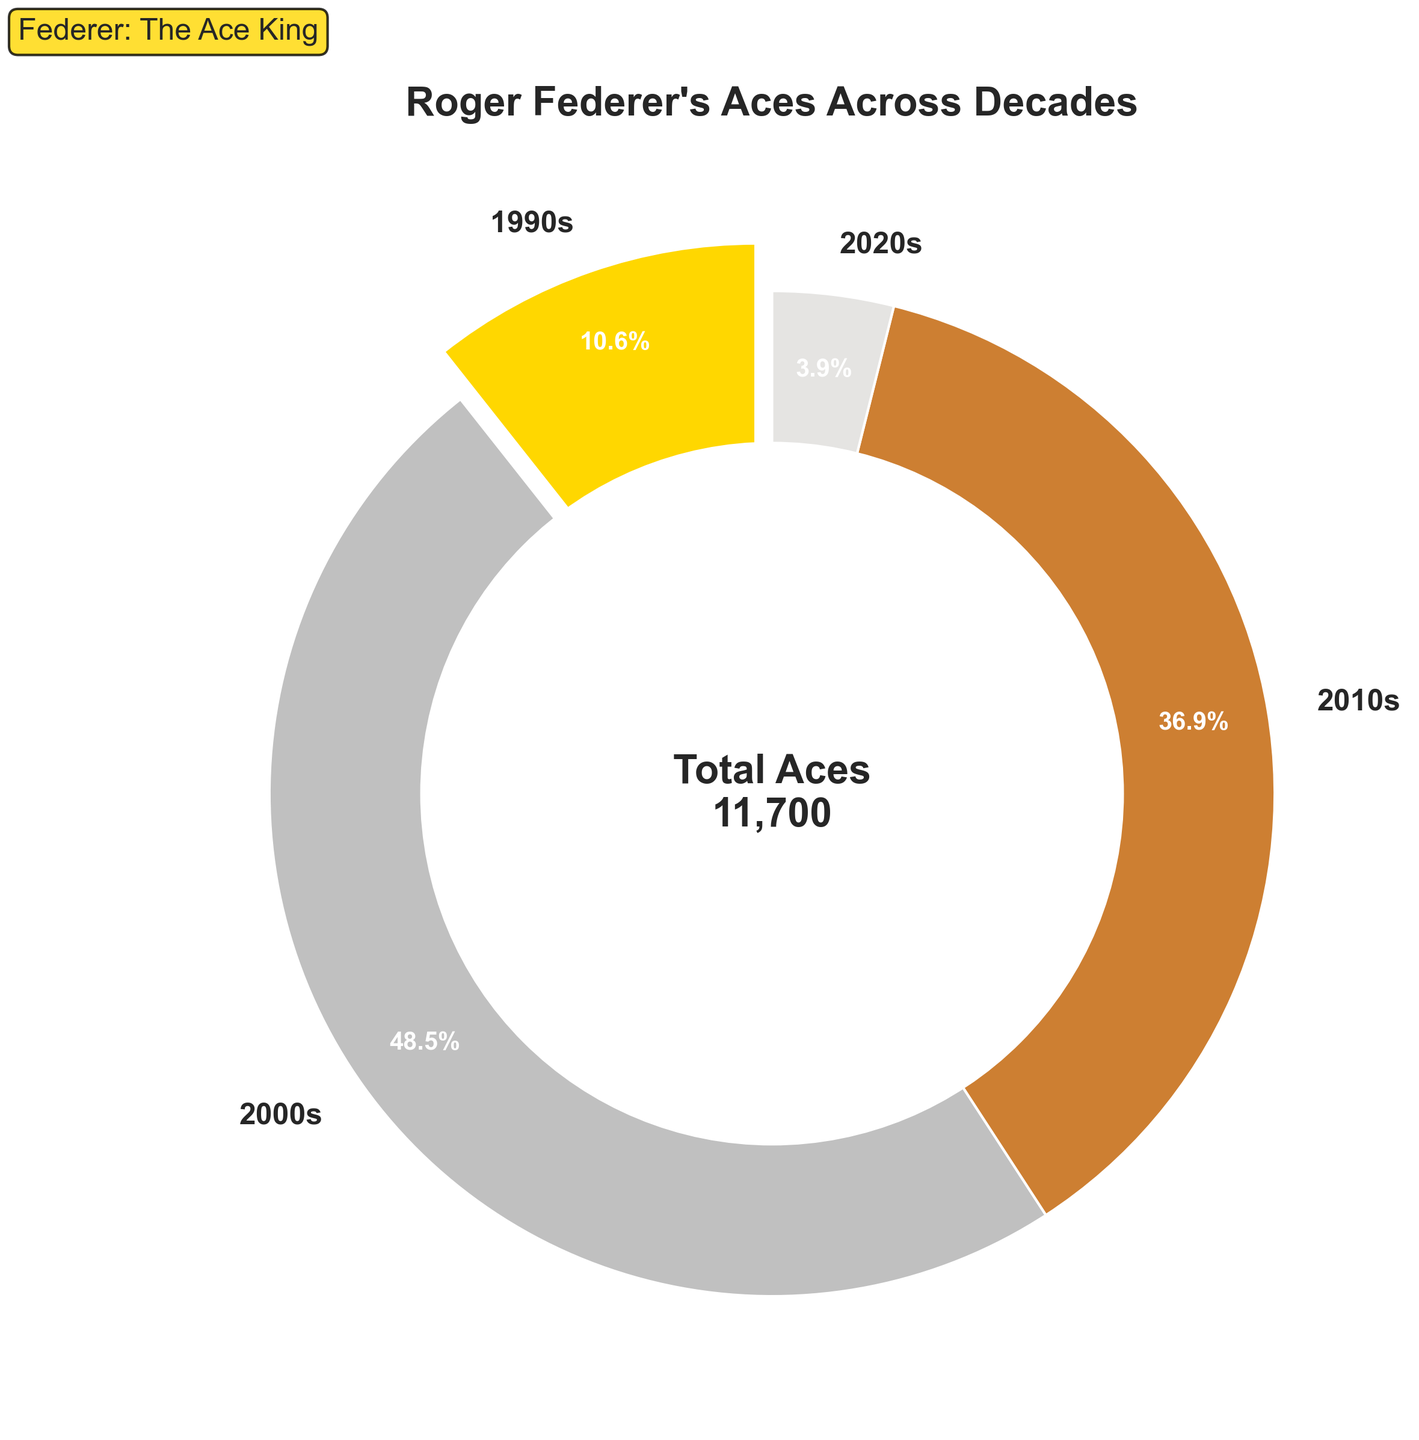What percentage of Roger Federer's total career aces were made in the 2000s? The figure shows that the 2000s segment is highlighted with an explosion and has a value. The 2000s segment shows 5678 aces out of the total, and the figure directly calculates and displays the percentage path around the wedge.
Answer: 54.9% How many aces did Roger Federer serve in the 2010s and 2020s combined? Add the number of aces from the 2010s and 2020s segments shown on the pie chart. 4321 (2010s) + 456 (2020s) = 4777.
Answer: 4777 Which decade had the lowest number of aces? Compare the sizes of the wedges and the aces' numbers in each segment. The 2020s wedge is the smallest with 456 aces.
Answer: 2020s How many more aces did Federer serve in the 2000s compared to the 1990s? Subtract the number of aces in the 1990s from the number in the 2000s. 5678 (2000s) - 1245 (1990s) = 4433.
Answer: 4433 What portion of Federer's total career aces were made before 2000? The total number of aces before 2000 is just from the 1990s segment, which is 1245. To find the portion, calculate 1245 out of the total sum. The total aces are 1245 + 5678 + 4321 + 456 = 11600. Portion calculation: 1245 / 11600 = 0.1073 or 10.7%.
Answer: 10.7% Did Federer serve more than 50% of his total career aces in any single decade? Look at the percentages in each wedge; the 2000s segment shows that 54.9% of his aces were served in that decade.
Answer: Yes, in the 2000s Which decade had the second highest number of aces? Compare the sizes of the wedges; the 2000s have the highest, followed by the 2010s with 4321 aces.
Answer: 2010s How does the number of aces served in the 2010s compare to the 1990s? Compare the values of the wedges. The 2010s have 4321 aces, while the 1990s have 1245. 4321 is more than 1245.
Answer: The 2010s had more What is the percentage difference in the number of aces between the 1990s and 2010s? Calculate percentages for the 1990s and 2010s. The pie chart gives total aces as 11600. The 1990s had 1245 aces, which is 1245 / 11600 * 100 ≈ 10.7%. The 2010s had 4321 aces, which is 4321 / 11600 * 100 ≈ 37.2%. Difference = 37.2% - 10.7% = 26.5%.
Answer: 26.5% What's the approximate percentage of Federer's aces made post-2010 (2010s and 2020s combined)? Add the number of aces in the 2010s and 2020s, then divide by the total and multiply by 100. (4321 + 456) / 11600 * 100 ≈ 41.1%.
Answer: 41.1% 